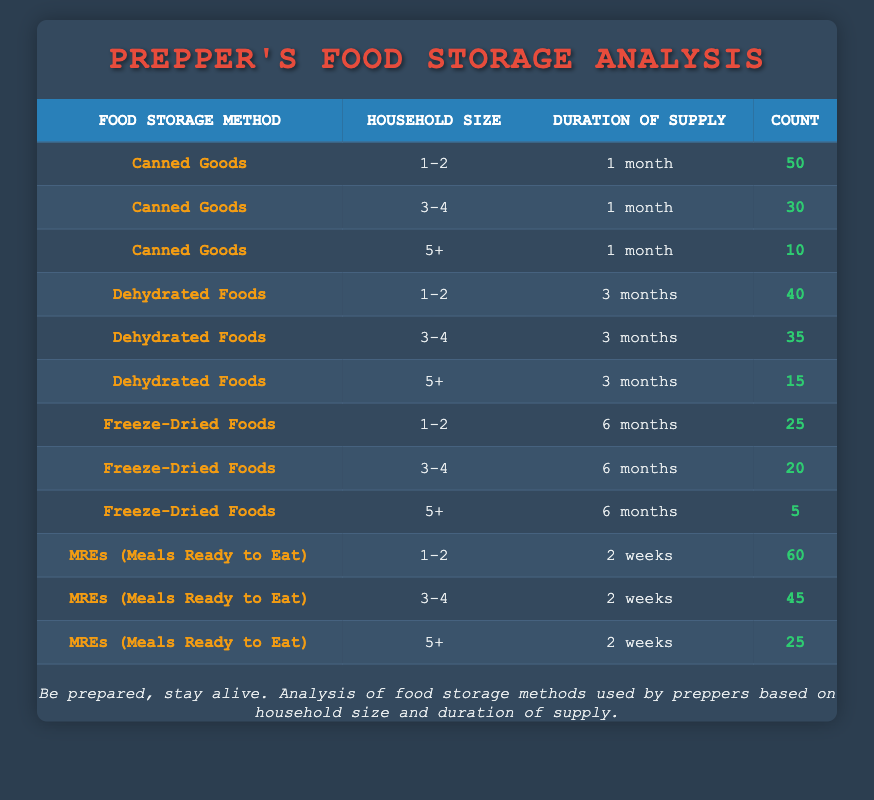What is the count of preppers using MREs for households of size 3-4? The table shows that the count for MREs (Meals Ready to Eat) for household size 3-4 is 45.
Answer: 45 What is the total count of Canned Goods across all household sizes and durations of supply? The count for Canned Goods for household sizes is 50 (1-2) + 30 (3-4) + 10 (5+) = 90.
Answer: 90 Is Freeze-Dried Foods used more by larger households than Canned Goods? The count for Freeze-Dried Foods for household size 5+ is 5, while for Canned Goods it is 10. Therefore, Freeze-Dried Foods is used less by larger households.
Answer: No What is the average count of preppers using Dehydrated Foods across all household sizes? The counts for Dehydrated Foods are 40 (1-2) + 35 (3-4) + 15 (5+) = 90, and there are 3 household sizes. So, the average is 90/3 = 30.
Answer: 30 Which food storage method has the highest count for household size 1-2? MREs (Meals Ready to Eat) has the highest count of 60 for household size 1-2, which is greater than the counts for Canned Goods (50) and Dehydrated Foods (40).
Answer: MREs (Meals Ready to Eat) What is the difference in counts between Dehydrated Foods and MREs for household size 5+? The count for Dehydrated Foods (5+) is 15, and for MREs (5+) it is 25. The difference is 25 - 15 = 10.
Answer: 10 